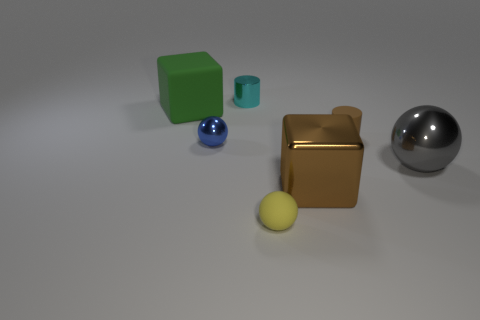How many objects are either brown metallic objects or small yellow metallic cylinders?
Give a very brief answer. 1. Is the material of the big block in front of the small blue sphere the same as the brown cylinder?
Give a very brief answer. No. What number of objects are spheres that are in front of the blue metal ball or matte cylinders?
Provide a short and direct response. 3. What is the color of the tiny ball that is made of the same material as the big brown thing?
Ensure brevity in your answer.  Blue. Is there a gray object of the same size as the green thing?
Offer a very short reply. Yes. There is a large cube that is to the right of the yellow rubber thing; does it have the same color as the small metal cylinder?
Your response must be concise. No. There is a tiny thing that is behind the tiny blue metallic object and on the left side of the small brown object; what color is it?
Ensure brevity in your answer.  Cyan. The blue thing that is the same size as the brown rubber cylinder is what shape?
Offer a very short reply. Sphere. Is there another large yellow rubber thing of the same shape as the big rubber thing?
Offer a very short reply. No. Does the cylinder that is on the left side of the yellow rubber object have the same size as the tiny brown matte object?
Keep it short and to the point. Yes. 